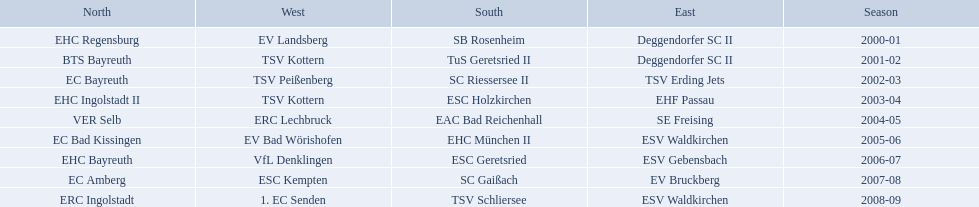Which teams have won in the bavarian ice hockey leagues between 2000 and 2009? EHC Regensburg, SB Rosenheim, Deggendorfer SC II, EV Landsberg, BTS Bayreuth, TuS Geretsried II, TSV Kottern, EC Bayreuth, SC Riessersee II, TSV Erding Jets, TSV Peißenberg, EHC Ingolstadt II, ESC Holzkirchen, EHF Passau, TSV Kottern, VER Selb, EAC Bad Reichenhall, SE Freising, ERC Lechbruck, EC Bad Kissingen, EHC München II, ESV Waldkirchen, EV Bad Wörishofen, EHC Bayreuth, ESC Geretsried, ESV Gebensbach, VfL Denklingen, EC Amberg, SC Gaißach, EV Bruckberg, ESC Kempten, ERC Ingolstadt, TSV Schliersee, ESV Waldkirchen, 1. EC Senden. Which of these winning teams have won the north? EHC Regensburg, BTS Bayreuth, EC Bayreuth, EHC Ingolstadt II, VER Selb, EC Bad Kissingen, EHC Bayreuth, EC Amberg, ERC Ingolstadt. Which of the teams that won the north won in the 2000/2001 season? EHC Regensburg. 